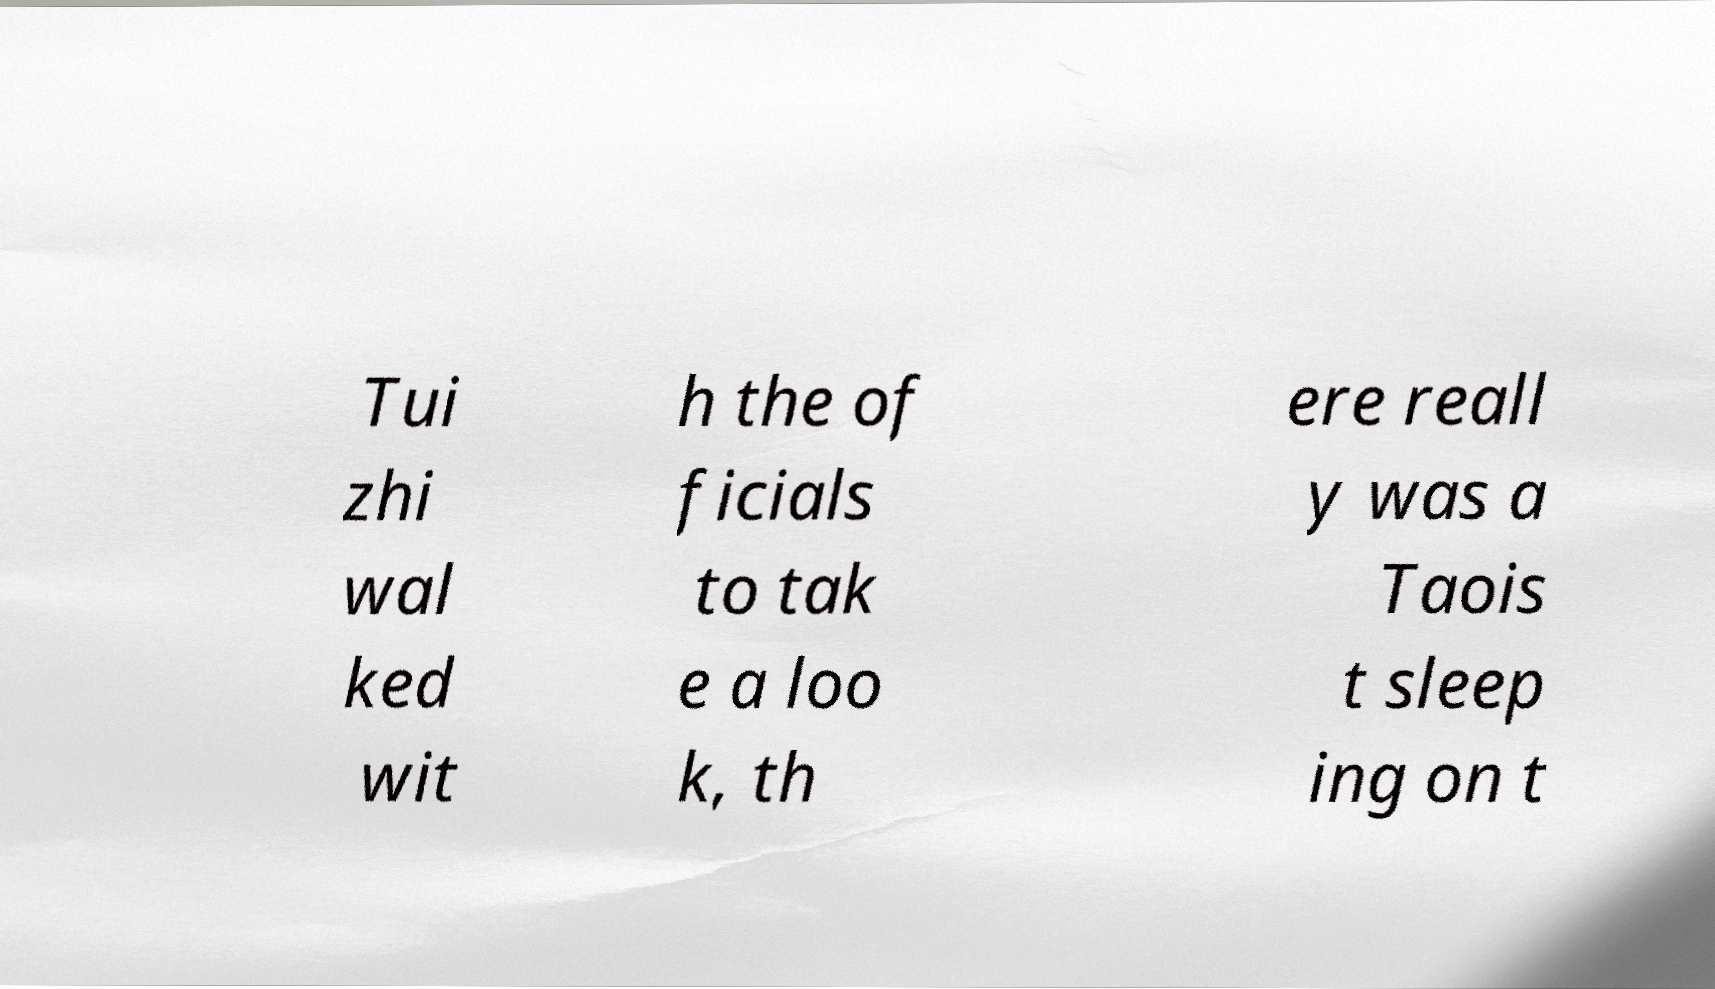Please identify and transcribe the text found in this image. Tui zhi wal ked wit h the of ficials to tak e a loo k, th ere reall y was a Taois t sleep ing on t 